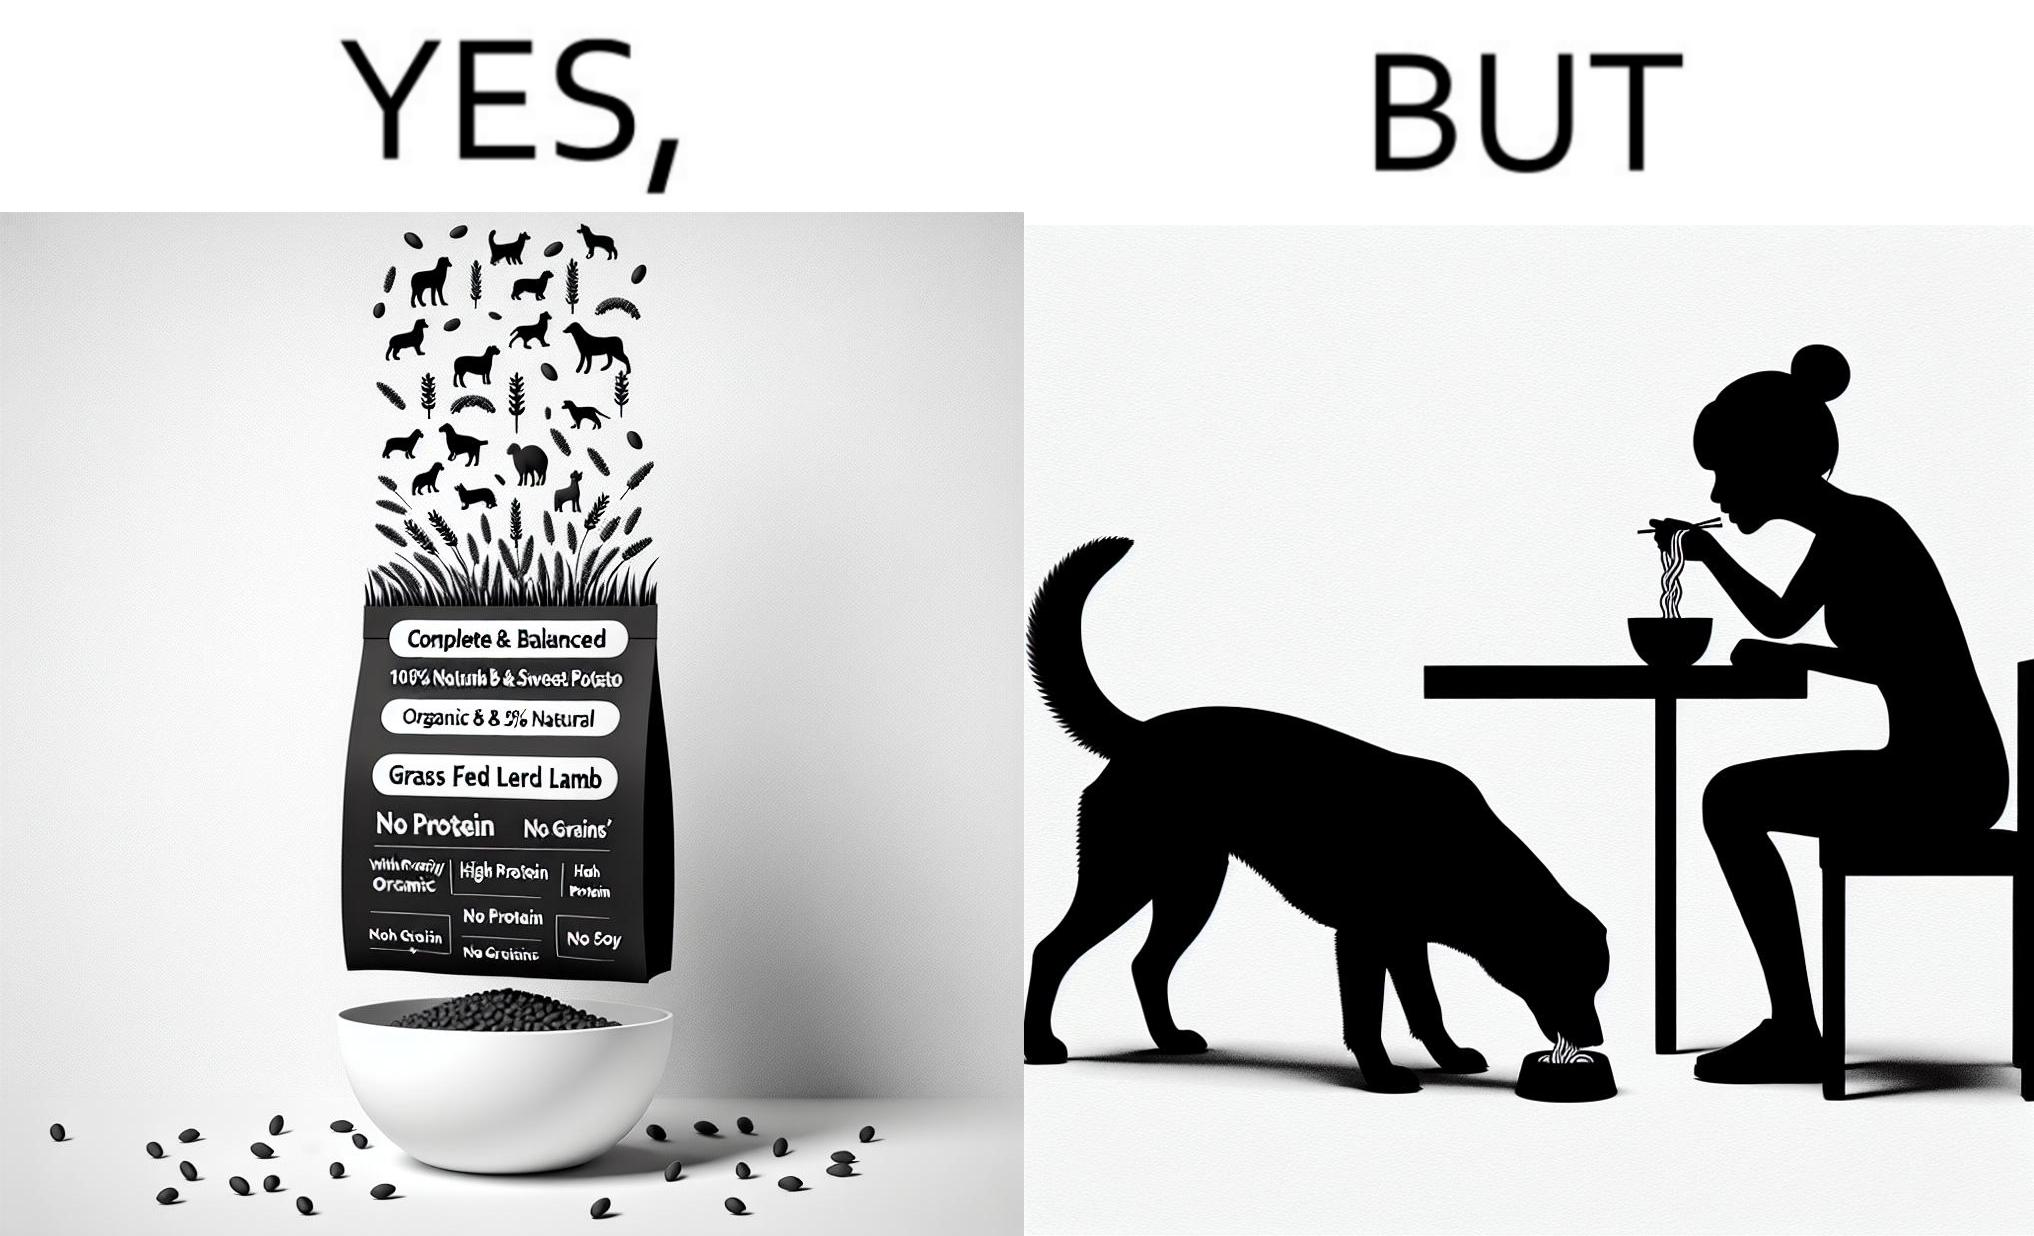What does this image depict? The image is funny because while the food for the dog that the woman pours is well balanced, the food that she herself is eating is bad for her health. 